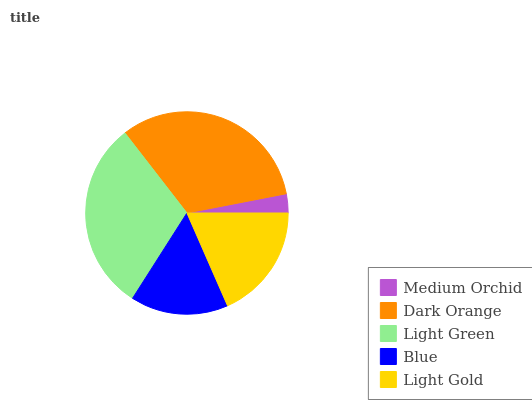Is Medium Orchid the minimum?
Answer yes or no. Yes. Is Dark Orange the maximum?
Answer yes or no. Yes. Is Light Green the minimum?
Answer yes or no. No. Is Light Green the maximum?
Answer yes or no. No. Is Dark Orange greater than Light Green?
Answer yes or no. Yes. Is Light Green less than Dark Orange?
Answer yes or no. Yes. Is Light Green greater than Dark Orange?
Answer yes or no. No. Is Dark Orange less than Light Green?
Answer yes or no. No. Is Light Gold the high median?
Answer yes or no. Yes. Is Light Gold the low median?
Answer yes or no. Yes. Is Blue the high median?
Answer yes or no. No. Is Light Green the low median?
Answer yes or no. No. 